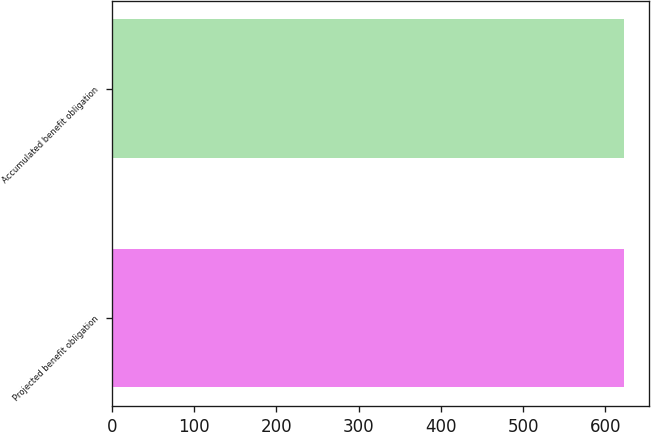Convert chart. <chart><loc_0><loc_0><loc_500><loc_500><bar_chart><fcel>Projected benefit obligation<fcel>Accumulated benefit obligation<nl><fcel>622<fcel>622.1<nl></chart> 